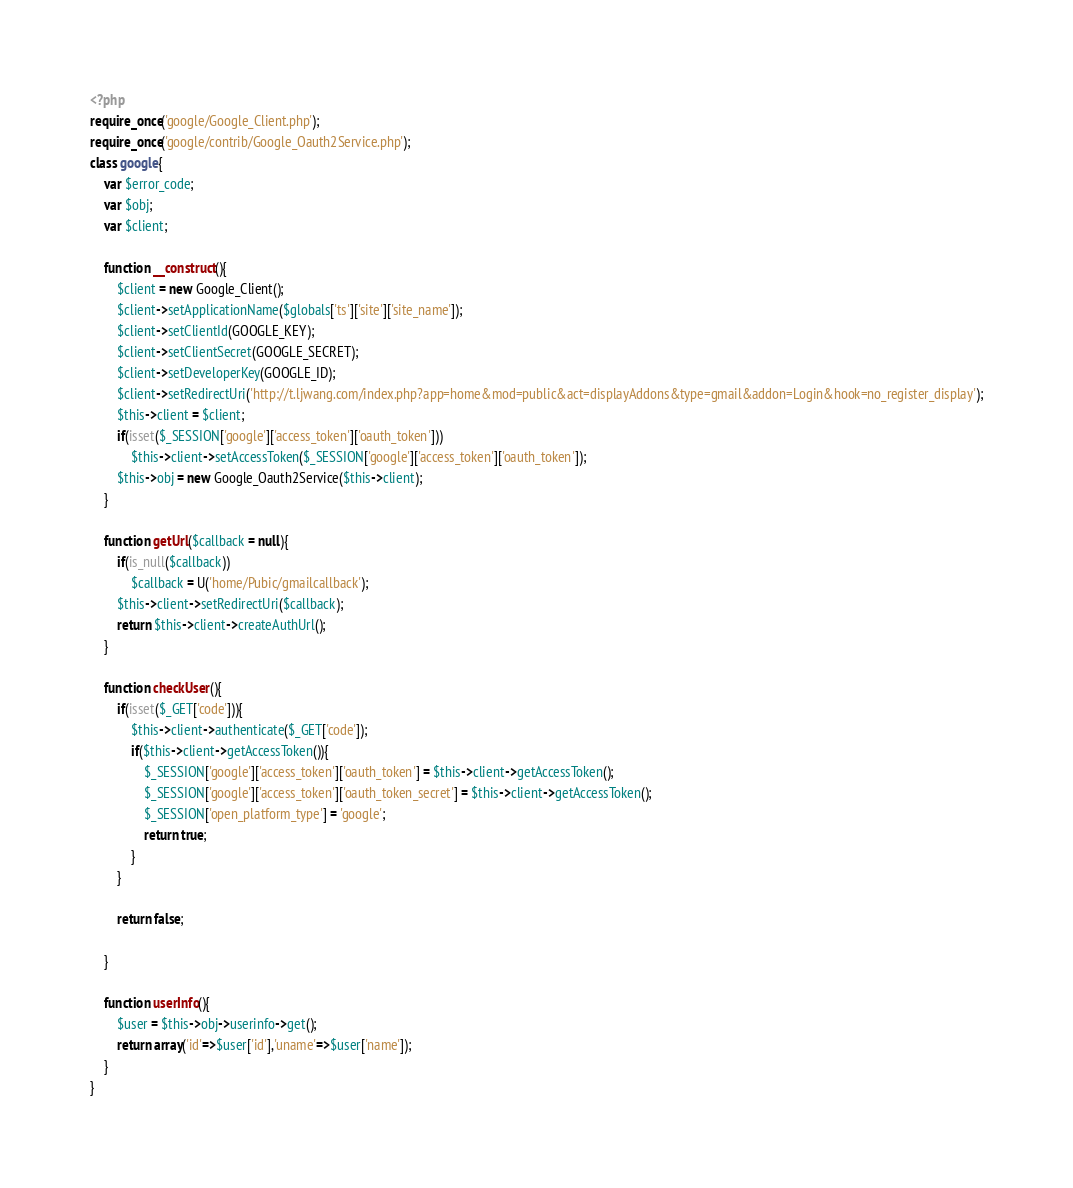Convert code to text. <code><loc_0><loc_0><loc_500><loc_500><_PHP_><?php
require_once('google/Google_Client.php');
require_once('google/contrib/Google_Oauth2Service.php');
class google{
	var $error_code;
	var $obj;
	var $client;
	
	function __construct(){
		$client = new Google_Client();
		$client->setApplicationName($globals['ts']['site']['site_name']);
		$client->setClientId(GOOGLE_KEY);
		$client->setClientSecret(GOOGLE_SECRET);
		$client->setDeveloperKey(GOOGLE_ID);
		$client->setRedirectUri('http://t.ljwang.com/index.php?app=home&mod=public&act=displayAddons&type=gmail&addon=Login&hook=no_register_display');
		$this->client = $client;
		if(isset($_SESSION['google']['access_token']['oauth_token']))
			$this->client->setAccessToken($_SESSION['google']['access_token']['oauth_token']);
		$this->obj = new Google_Oauth2Service($this->client);
	}
	
	function getUrl($callback = null){
		if(is_null($callback))
			$callback = U('home/Pubic/gmailcallback');
		$this->client->setRedirectUri($callback);
		return $this->client->createAuthUrl();
	}
	
	function checkUser(){
		if(isset($_GET['code'])){
			$this->client->authenticate($_GET['code']);
			if($this->client->getAccessToken()){
				$_SESSION['google']['access_token']['oauth_token'] = $this->client->getAccessToken();
				$_SESSION['google']['access_token']['oauth_token_secret'] = $this->client->getAccessToken();
				$_SESSION['open_platform_type'] = 'google';
				return true;
			}
		}
		
		return false;
	
	}
	
	function userInfo(){
		$user = $this->obj->userinfo->get();
		return array('id'=>$user['id'],'uname'=>$user['name']);
	}
}</code> 